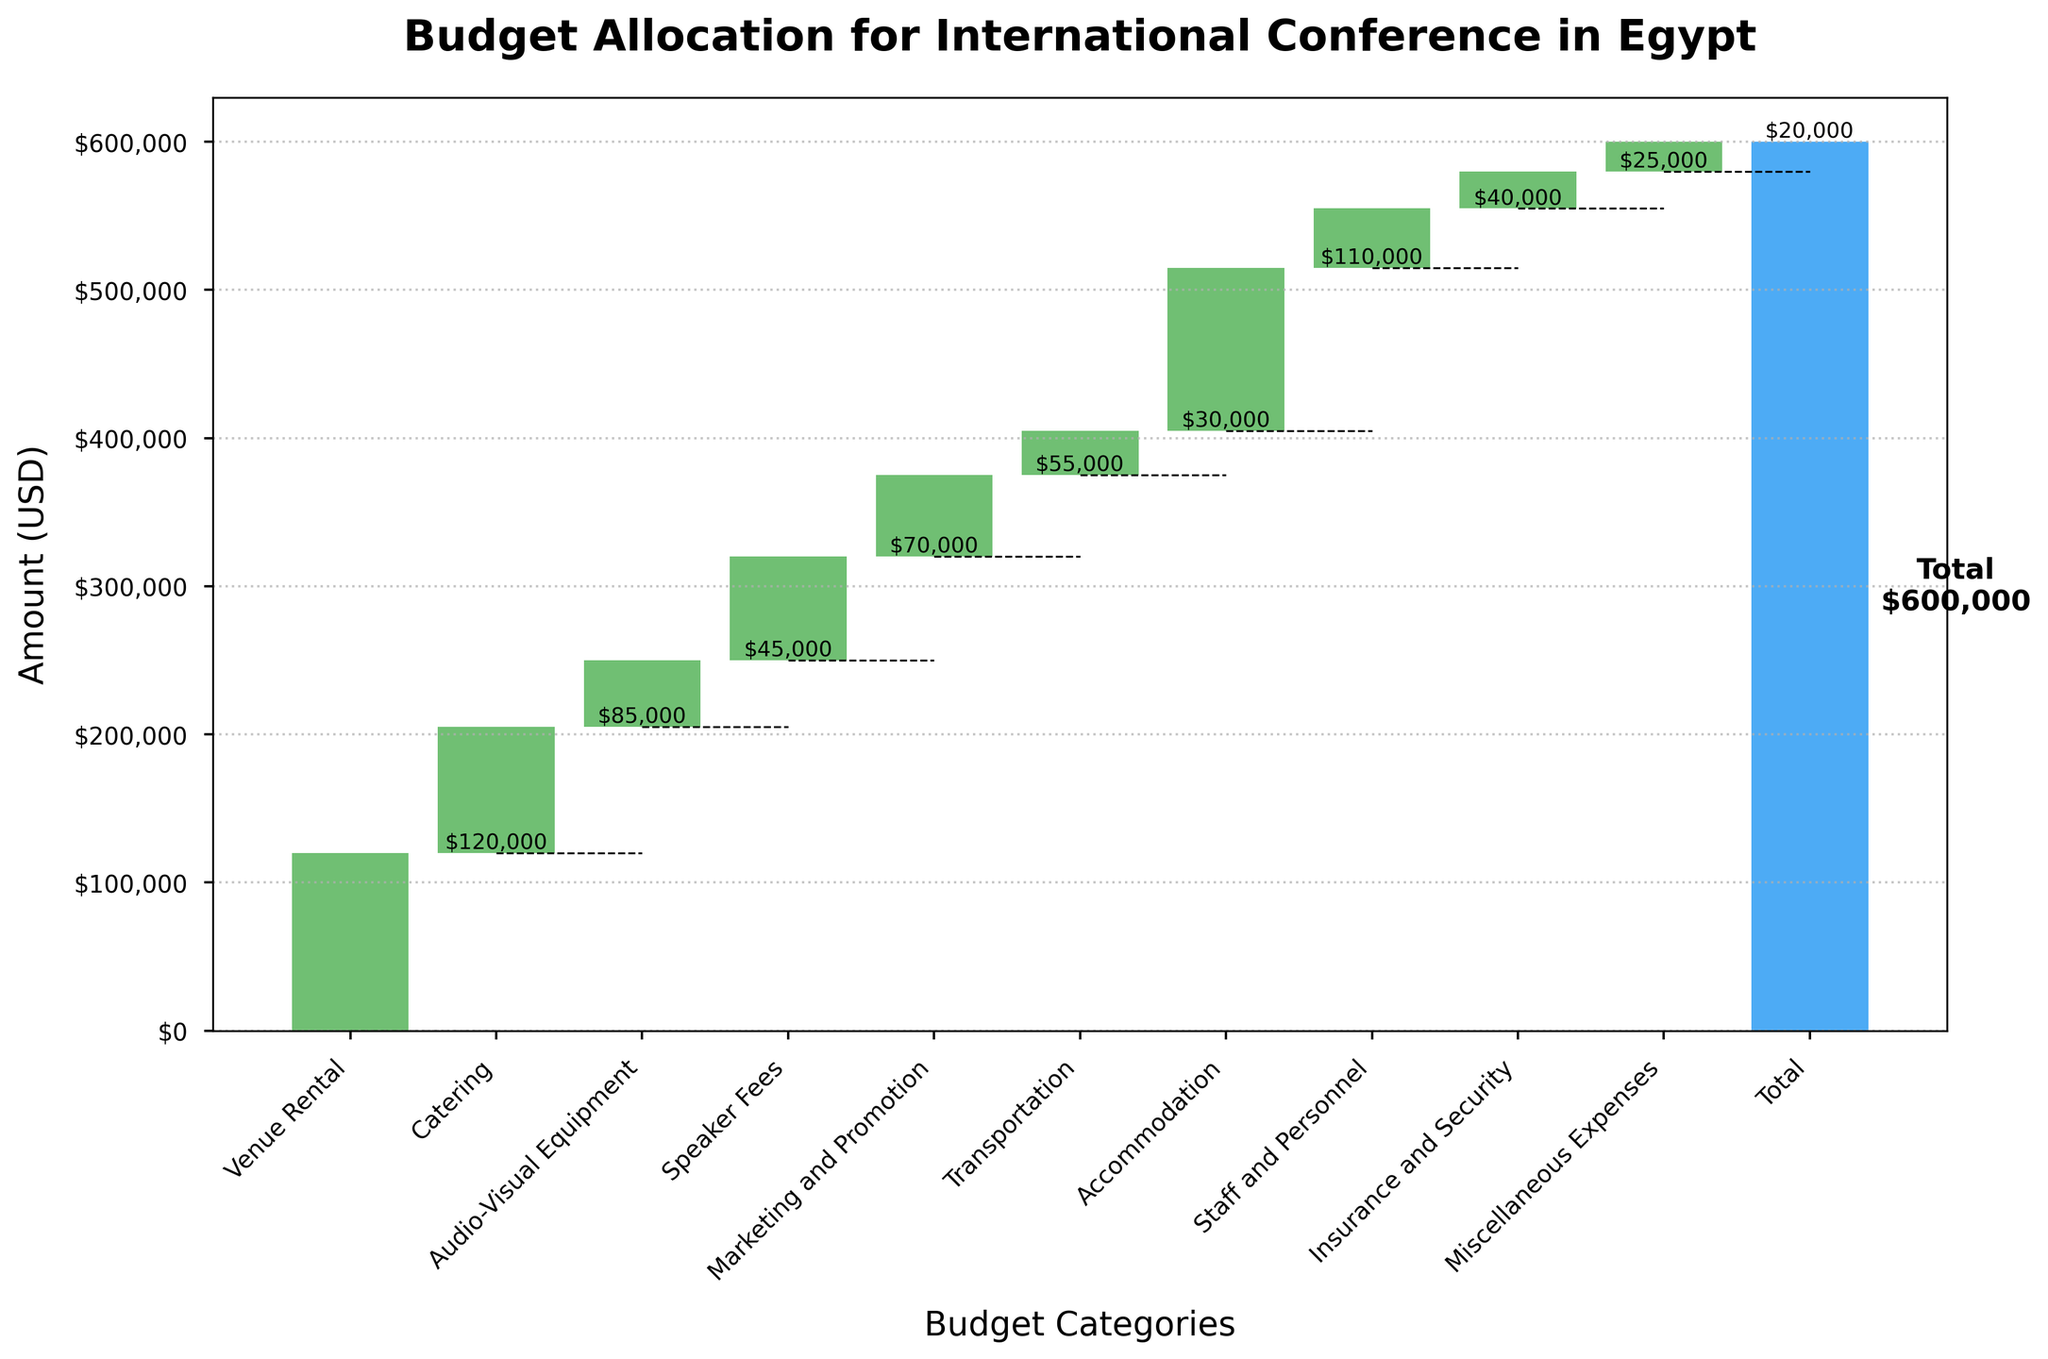What is the title of the figure? The title of the figure is displayed at the top, summarily describing the content of the plot, which is 'Budget Allocation for International Conference in Egypt'.
Answer: Budget Allocation for International Conference in Egypt How much was spent on Catering? The value on the bar labeled ‘Catering’ represents the amount spent on this category.
Answer: $85,000 Which category had the highest budget allocation? By comparing the heights of the bars, 'Venue Rental' has the highest value as indicated by the tallest bar.
Answer: Venue Rental What is the total budget allocated for the conference? The total budget is indicated by the bar labeled 'Total' at the end of the chart, which sums up all previous categories.
Answer: $600,000 What is the difference in budget allocation between 'Accommodation' and 'Transportation'? Subtract the budget for 'Transportation' from the budget for 'Accommodation': $110,000 - $30,000 = $80,000.
Answer: $80,000 How does the budget for 'Marketing and Promotion' compare to 'Speaker Fees'? Compare the budget values of 'Marketing and Promotion' and 'Speaker Fees'; $55,000 for Marketing and Promotion is less than $70,000 for Speaker Fees.
Answer: Less Which categories are included in this budget allocation? Categories can be observed from the x-axis labels: 'Venue Rental', 'Catering', 'Audio-Visual Equipment', 'Speaker Fees', 'Marketing and Promotion', 'Transportation', 'Accommodation', 'Staff and Personnel', 'Insurance and Security', 'Miscellaneous Expenses'.
Answer: Venue Rental, Catering, Audio-Visual Equipment, Speaker Fees, Marketing and Promotion, Transportation, Accommodation, Staff and Personnel, Insurance and Security, Miscellaneous Expenses What percentage of the total budget is allocated to 'Speaker Fees'? Divide the amount for 'Speaker Fees' by the total budget and multiply by 100: ($70,000 / $600,000) * 100 = 11.67%.
Answer: 11.67% How much was spent on 'Staff and Personnel' if it is combined with 'Insurance and Security'? Add the amounts for 'Staff and Personnel' and 'Insurance and Security': $40,000 + $25,000 = $65,000.
Answer: $65,000 Which category had the smallest budget allocation? By identifying the shortest bar, 'Miscellaneous Expenses' has the smallest budget allocation.
Answer: Miscellaneous Expenses 